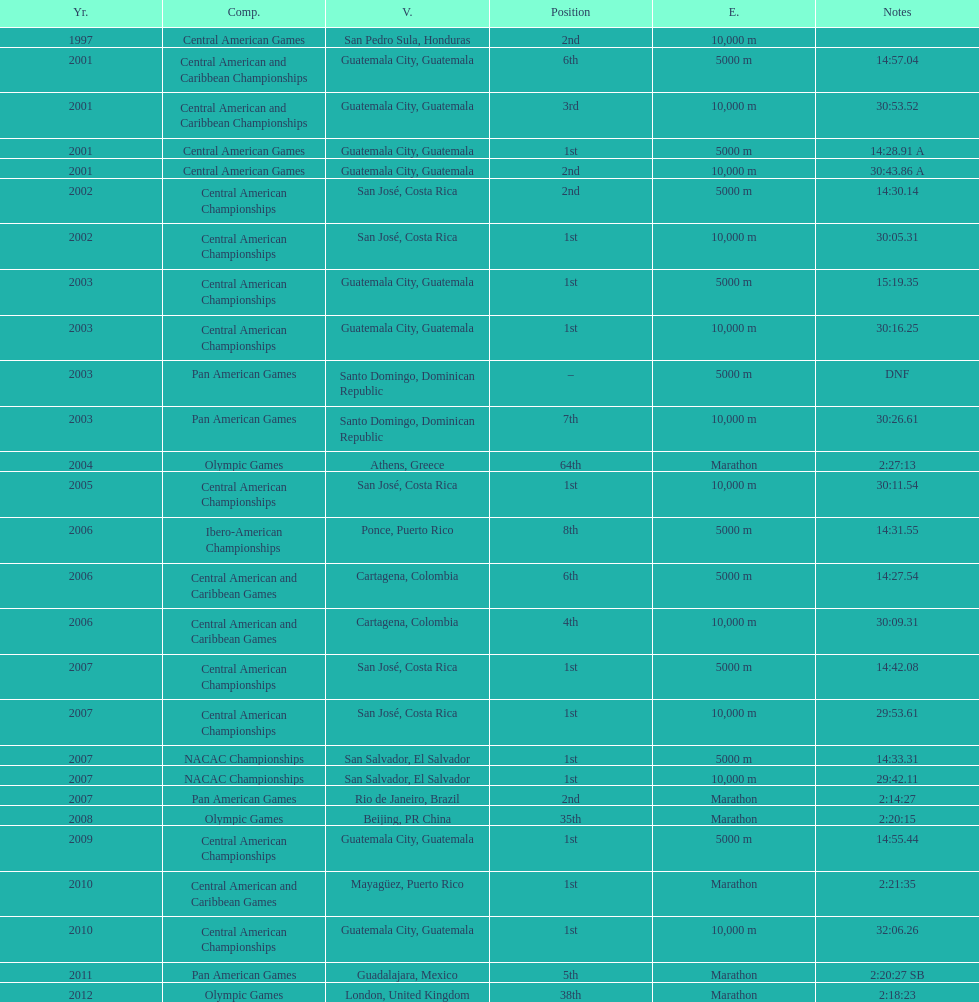Tell me the number of times they competed in guatamala. 5. 